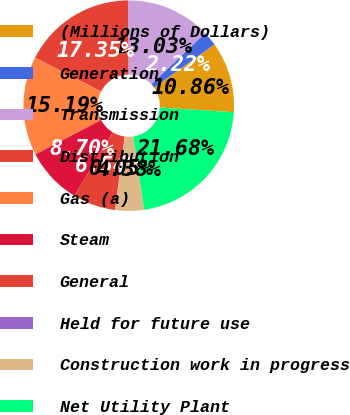<chart> <loc_0><loc_0><loc_500><loc_500><pie_chart><fcel>(Millions of Dollars)<fcel>Generation<fcel>Transmission<fcel>Distribution<fcel>Gas (a)<fcel>Steam<fcel>General<fcel>Held for future use<fcel>Construction work in progress<fcel>Net Utility Plant<nl><fcel>10.86%<fcel>2.22%<fcel>13.03%<fcel>17.35%<fcel>15.19%<fcel>8.7%<fcel>6.54%<fcel>0.05%<fcel>4.38%<fcel>21.68%<nl></chart> 